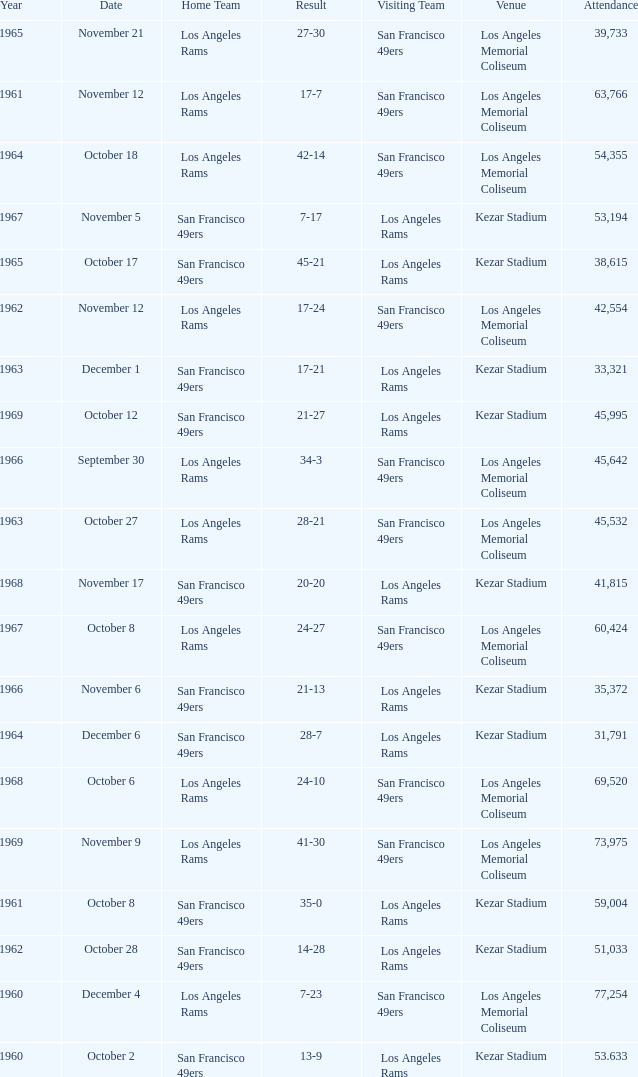Parse the full table. {'header': ['Year', 'Date', 'Home Team', 'Result', 'Visiting Team', 'Venue', 'Attendance'], 'rows': [['1965', 'November 21', 'Los Angeles Rams', '27-30', 'San Francisco 49ers', 'Los Angeles Memorial Coliseum', '39,733'], ['1961', 'November 12', 'Los Angeles Rams', '17-7', 'San Francisco 49ers', 'Los Angeles Memorial Coliseum', '63,766'], ['1964', 'October 18', 'Los Angeles Rams', '42-14', 'San Francisco 49ers', 'Los Angeles Memorial Coliseum', '54,355'], ['1967', 'November 5', 'San Francisco 49ers', '7-17', 'Los Angeles Rams', 'Kezar Stadium', '53,194'], ['1965', 'October 17', 'San Francisco 49ers', '45-21', 'Los Angeles Rams', 'Kezar Stadium', '38,615'], ['1962', 'November 12', 'Los Angeles Rams', '17-24', 'San Francisco 49ers', 'Los Angeles Memorial Coliseum', '42,554'], ['1963', 'December 1', 'San Francisco 49ers', '17-21', 'Los Angeles Rams', 'Kezar Stadium', '33,321'], ['1969', 'October 12', 'San Francisco 49ers', '21-27', 'Los Angeles Rams', 'Kezar Stadium', '45,995'], ['1966', 'September 30', 'Los Angeles Rams', '34-3', 'San Francisco 49ers', 'Los Angeles Memorial Coliseum', '45,642'], ['1963', 'October 27', 'Los Angeles Rams', '28-21', 'San Francisco 49ers', 'Los Angeles Memorial Coliseum', '45,532'], ['1968', 'November 17', 'San Francisco 49ers', '20-20', 'Los Angeles Rams', 'Kezar Stadium', '41,815'], ['1967', 'October 8', 'Los Angeles Rams', '24-27', 'San Francisco 49ers', 'Los Angeles Memorial Coliseum', '60,424'], ['1966', 'November 6', 'San Francisco 49ers', '21-13', 'Los Angeles Rams', 'Kezar Stadium', '35,372'], ['1964', 'December 6', 'San Francisco 49ers', '28-7', 'Los Angeles Rams', 'Kezar Stadium', '31,791'], ['1968', 'October 6', 'Los Angeles Rams', '24-10', 'San Francisco 49ers', 'Los Angeles Memorial Coliseum', '69,520'], ['1969', 'November 9', 'Los Angeles Rams', '41-30', 'San Francisco 49ers', 'Los Angeles Memorial Coliseum', '73,975'], ['1961', 'October 8', 'San Francisco 49ers', '35-0', 'Los Angeles Rams', 'Kezar Stadium', '59,004'], ['1962', 'October 28', 'San Francisco 49ers', '14-28', 'Los Angeles Rams', 'Kezar Stadium', '51,033'], ['1960', 'December 4', 'Los Angeles Rams', '7-23', 'San Francisco 49ers', 'Los Angeles Memorial Coliseum', '77,254'], ['1960', 'October 2', 'San Francisco 49ers', '13-9', 'Los Angeles Rams', 'Kezar Stadium', '53.633']]} When was the earliest year when the attendance was 77,254? 1960.0. 